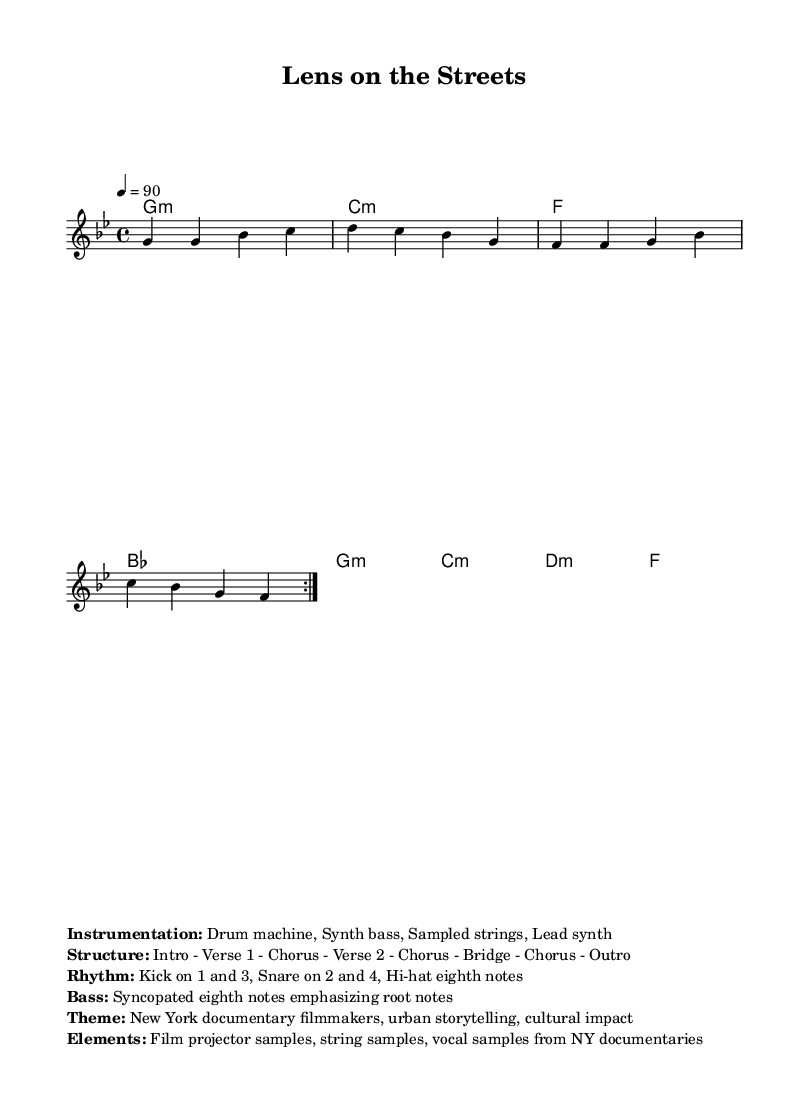What is the key signature of this music? The key signature is G minor, which has two flats (B♭ and E♭). This is indicated at the beginning of the music sheet, showing the specific notes to adjust throughout the piece.
Answer: G minor What is the time signature of this music? The time signature is 4/4, which means there are four beats in each measure and the quarter note gets one beat. This is typically placed at the beginning of the music sheet right after the key signature.
Answer: 4/4 What is the tempo marking of this music? The tempo marking is 90 beats per minute, indicated by the "4 = 90" notation, outlining the desired pace for the performance of the piece.
Answer: 90 What is the theme of the piece? The theme, as stated in the markup section, focuses on New York documentary filmmakers and their impact on urban storytelling and culture. This reflects the overall message and inspiration behind the music.
Answer: New York documentary filmmakers How many measures are in the melody section? The melody section contains 8 measures as indicated by the repetition noted by "\repeat volta 2", which suggests that the first part of the melody is played twice, resulting in 8 total measures.
Answer: 8 What instrument is primarily used to emphasize the rhythm? The drum machine is listed as the primary rhythm instrument in the instrumentation section, highlighting its crucial role in the hip-hop genre's beat foundation.
Answer: Drum machine How does the bassline in this piece emphasize the root notes? The bassline is described as syncopated eighth notes that emphasize the root notes, contributing to the characteristic groove of hip-hop tracks. This is a common technique in the genre to create a solid rhythmic foundation.
Answer: Syncopated eighth notes 